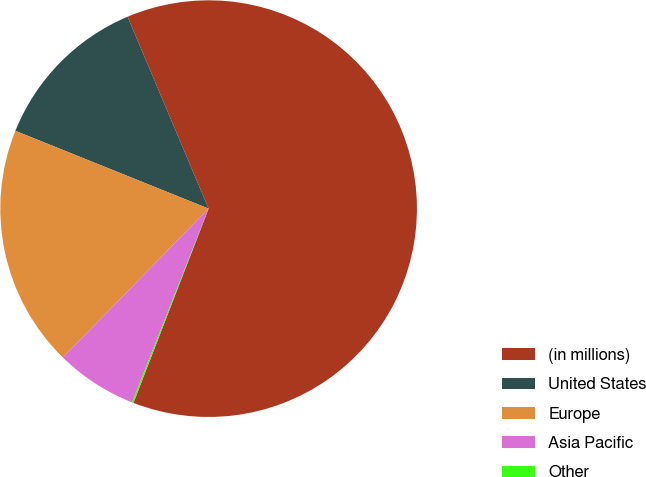Convert chart. <chart><loc_0><loc_0><loc_500><loc_500><pie_chart><fcel>(in millions)<fcel>United States<fcel>Europe<fcel>Asia Pacific<fcel>Other<nl><fcel>62.24%<fcel>12.55%<fcel>18.76%<fcel>6.34%<fcel>0.12%<nl></chart> 